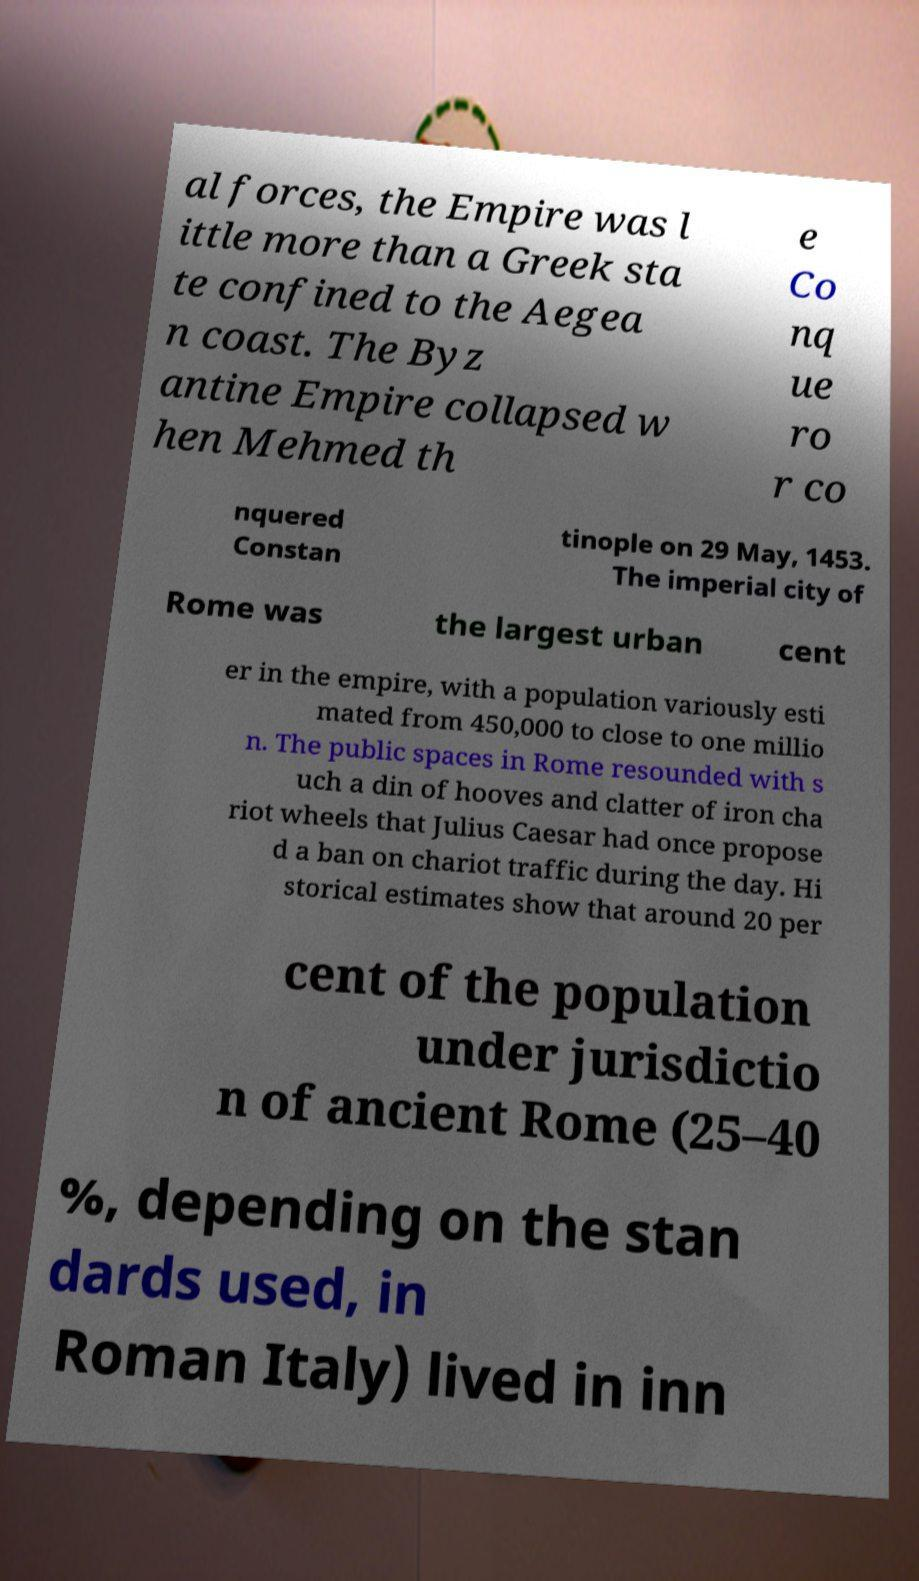For documentation purposes, I need the text within this image transcribed. Could you provide that? al forces, the Empire was l ittle more than a Greek sta te confined to the Aegea n coast. The Byz antine Empire collapsed w hen Mehmed th e Co nq ue ro r co nquered Constan tinople on 29 May, 1453. The imperial city of Rome was the largest urban cent er in the empire, with a population variously esti mated from 450,000 to close to one millio n. The public spaces in Rome resounded with s uch a din of hooves and clatter of iron cha riot wheels that Julius Caesar had once propose d a ban on chariot traffic during the day. Hi storical estimates show that around 20 per cent of the population under jurisdictio n of ancient Rome (25–40 %, depending on the stan dards used, in Roman Italy) lived in inn 